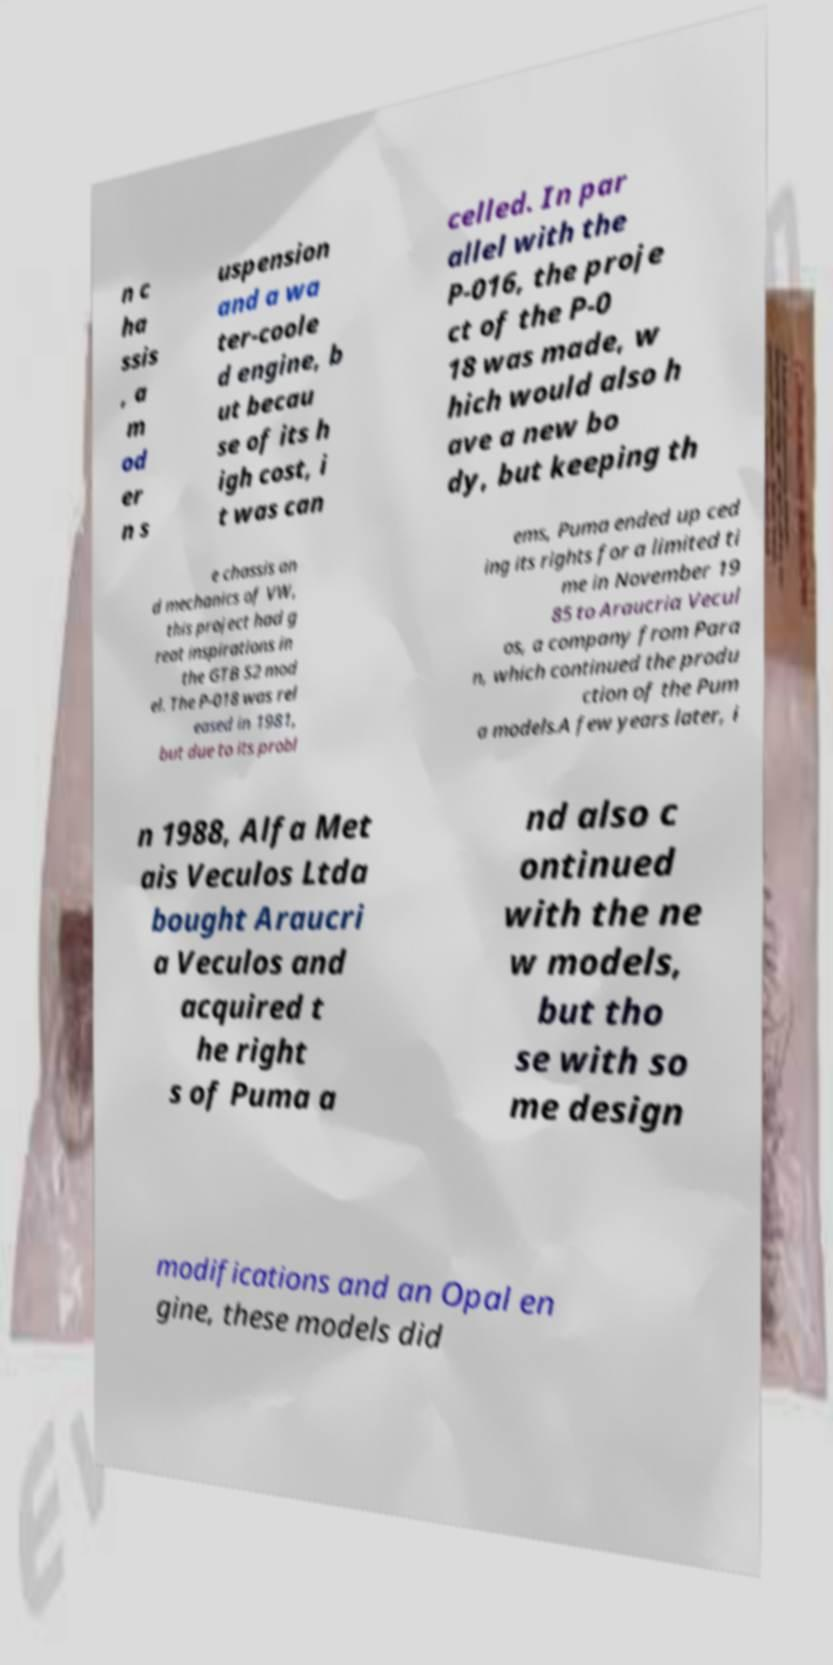Could you extract and type out the text from this image? n c ha ssis , a m od er n s uspension and a wa ter-coole d engine, b ut becau se of its h igh cost, i t was can celled. In par allel with the P-016, the proje ct of the P-0 18 was made, w hich would also h ave a new bo dy, but keeping th e chassis an d mechanics of VW, this project had g reat inspirations in the GTB S2 mod el. The P-018 was rel eased in 1981, but due to its probl ems, Puma ended up ced ing its rights for a limited ti me in November 19 85 to Araucria Vecul os, a company from Para n, which continued the produ ction of the Pum a models.A few years later, i n 1988, Alfa Met ais Veculos Ltda bought Araucri a Veculos and acquired t he right s of Puma a nd also c ontinued with the ne w models, but tho se with so me design modifications and an Opal en gine, these models did 